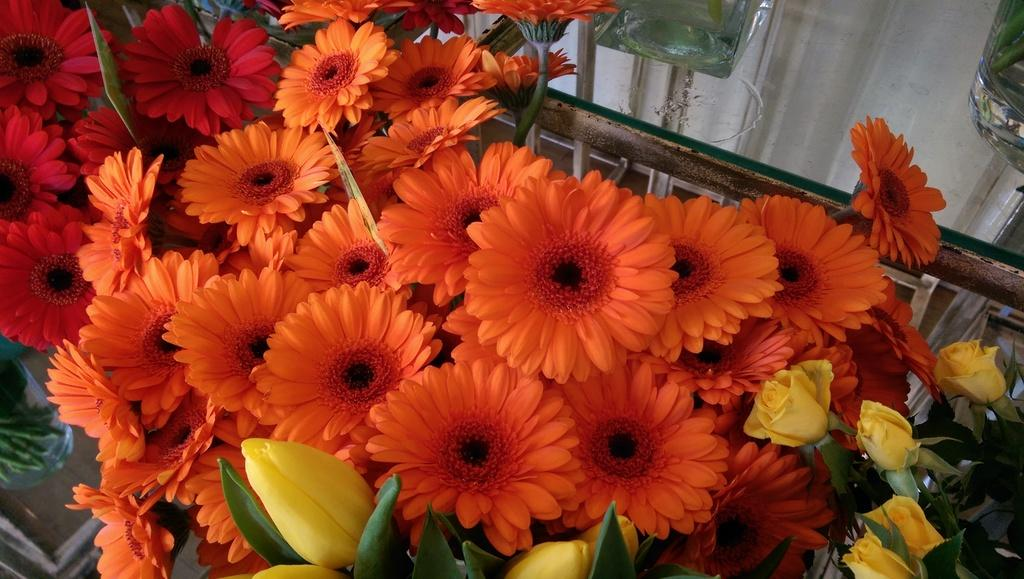What type of living organisms can be seen in the image? There are flowers in the image. What type of objects are made of glass in the image? There are glass objects in the image. What can be seen behind the flowers and glass objects in the image? The background of the image is visible. What type of science experiment is being conducted in the image? There is no science experiment present in the image; it features flowers and glass objects. What type of chain is visible in the image? There is no chain present in the image. 